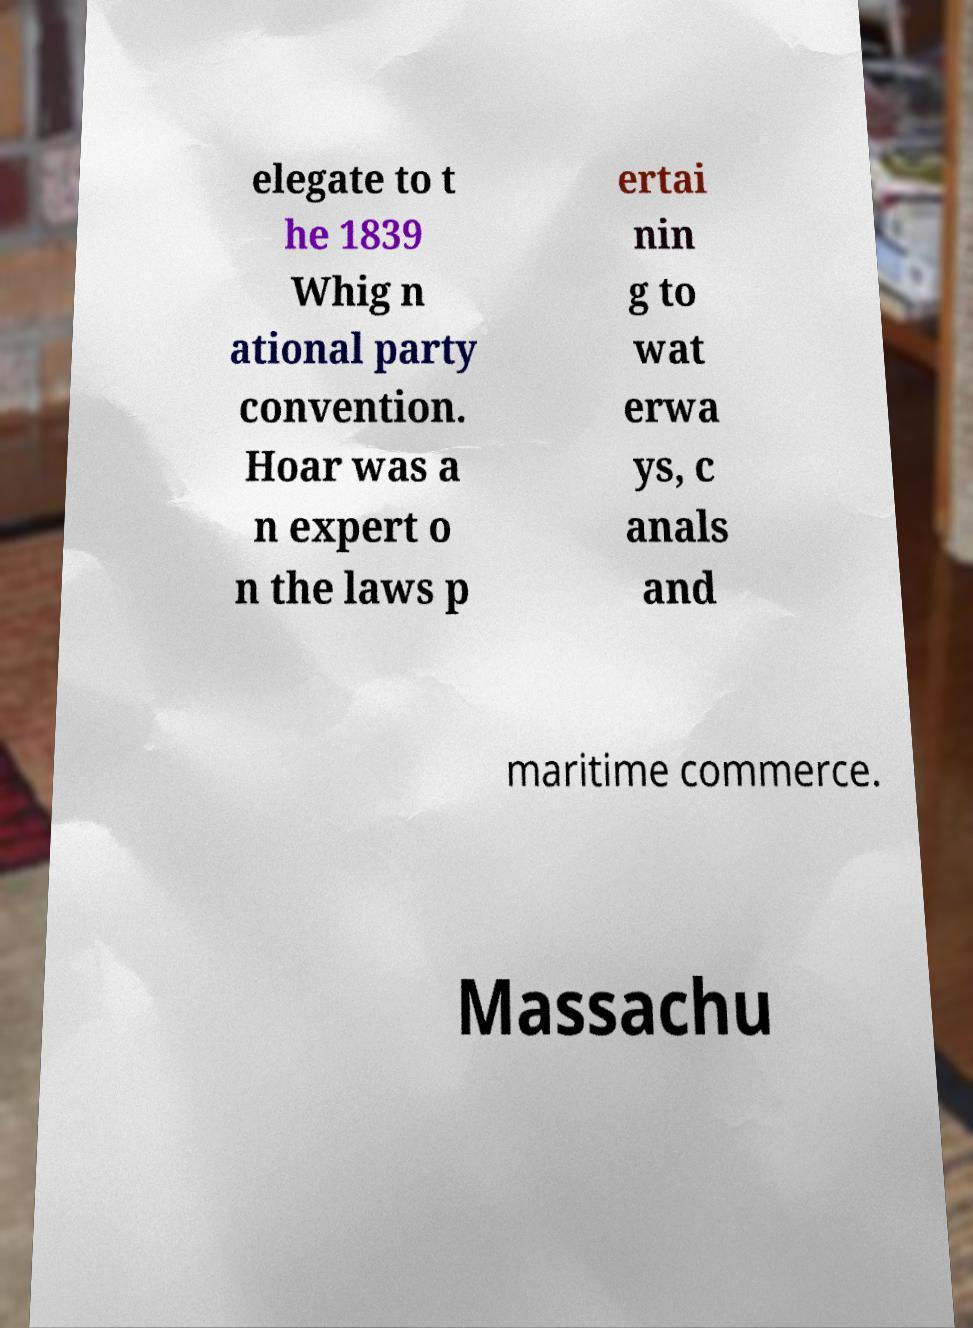Can you read and provide the text displayed in the image?This photo seems to have some interesting text. Can you extract and type it out for me? elegate to t he 1839 Whig n ational party convention. Hoar was a n expert o n the laws p ertai nin g to wat erwa ys, c anals and maritime commerce. Massachu 